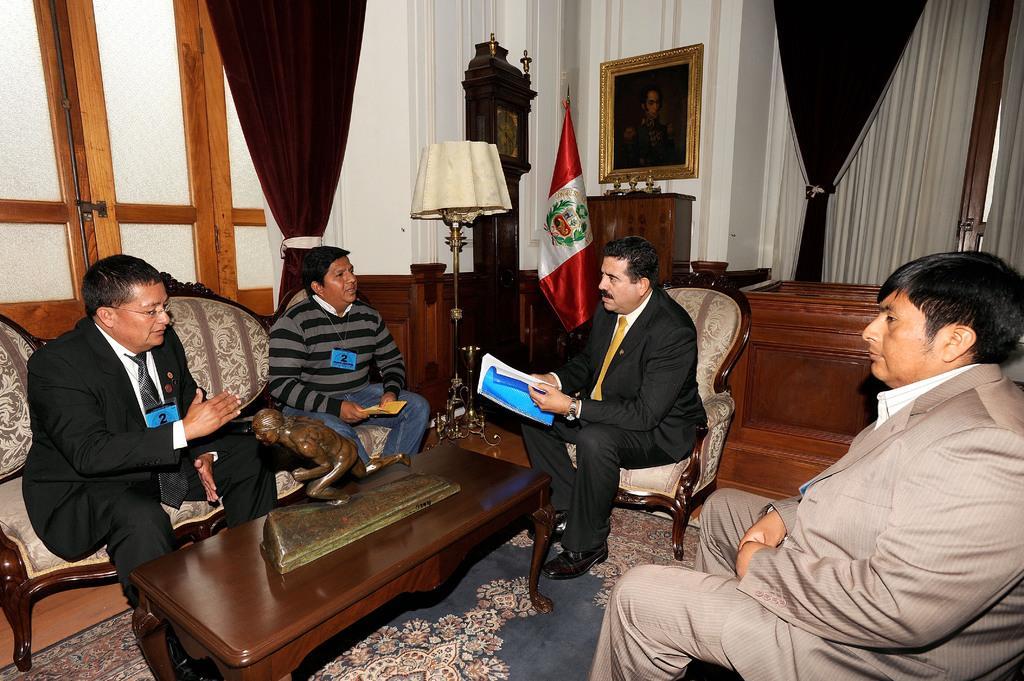Please provide a concise description of this image. Here we can see a group of people sitting on chairs with a table in front of them discussing something and the person in the middle is having a book in his hands and behind him we can see a flag post and a lamp and we can see curtains present and a portrait present 